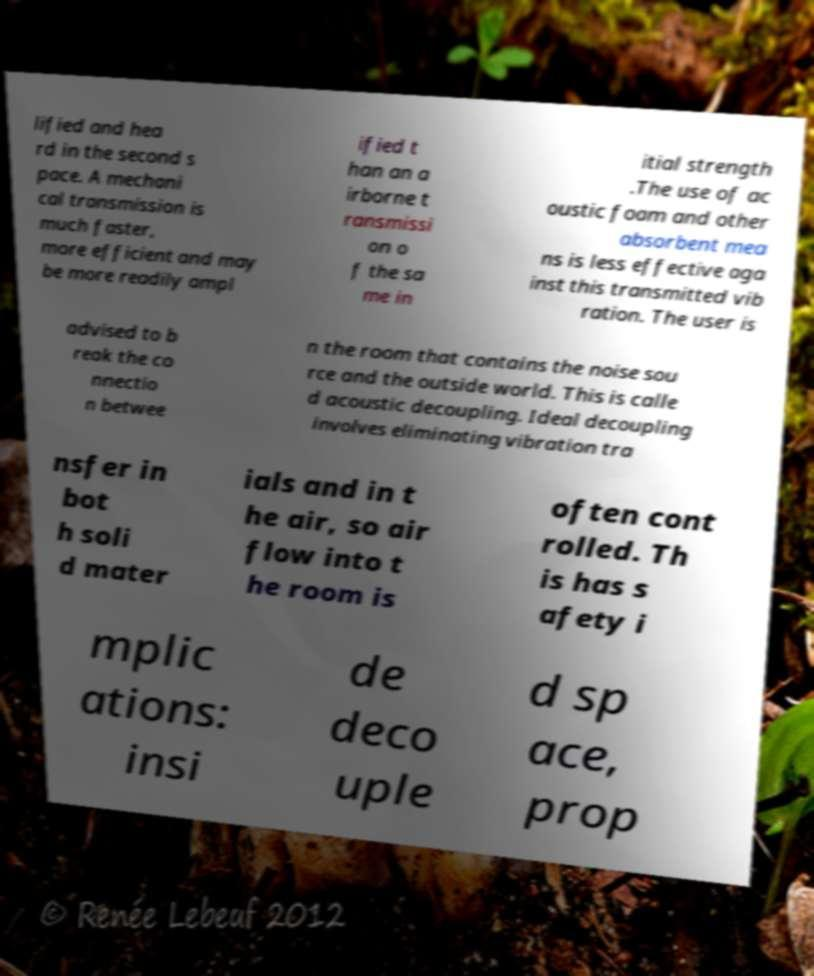Can you read and provide the text displayed in the image?This photo seems to have some interesting text. Can you extract and type it out for me? lified and hea rd in the second s pace. A mechani cal transmission is much faster, more efficient and may be more readily ampl ified t han an a irborne t ransmissi on o f the sa me in itial strength .The use of ac oustic foam and other absorbent mea ns is less effective aga inst this transmitted vib ration. The user is advised to b reak the co nnectio n betwee n the room that contains the noise sou rce and the outside world. This is calle d acoustic decoupling. Ideal decoupling involves eliminating vibration tra nsfer in bot h soli d mater ials and in t he air, so air flow into t he room is often cont rolled. Th is has s afety i mplic ations: insi de deco uple d sp ace, prop 